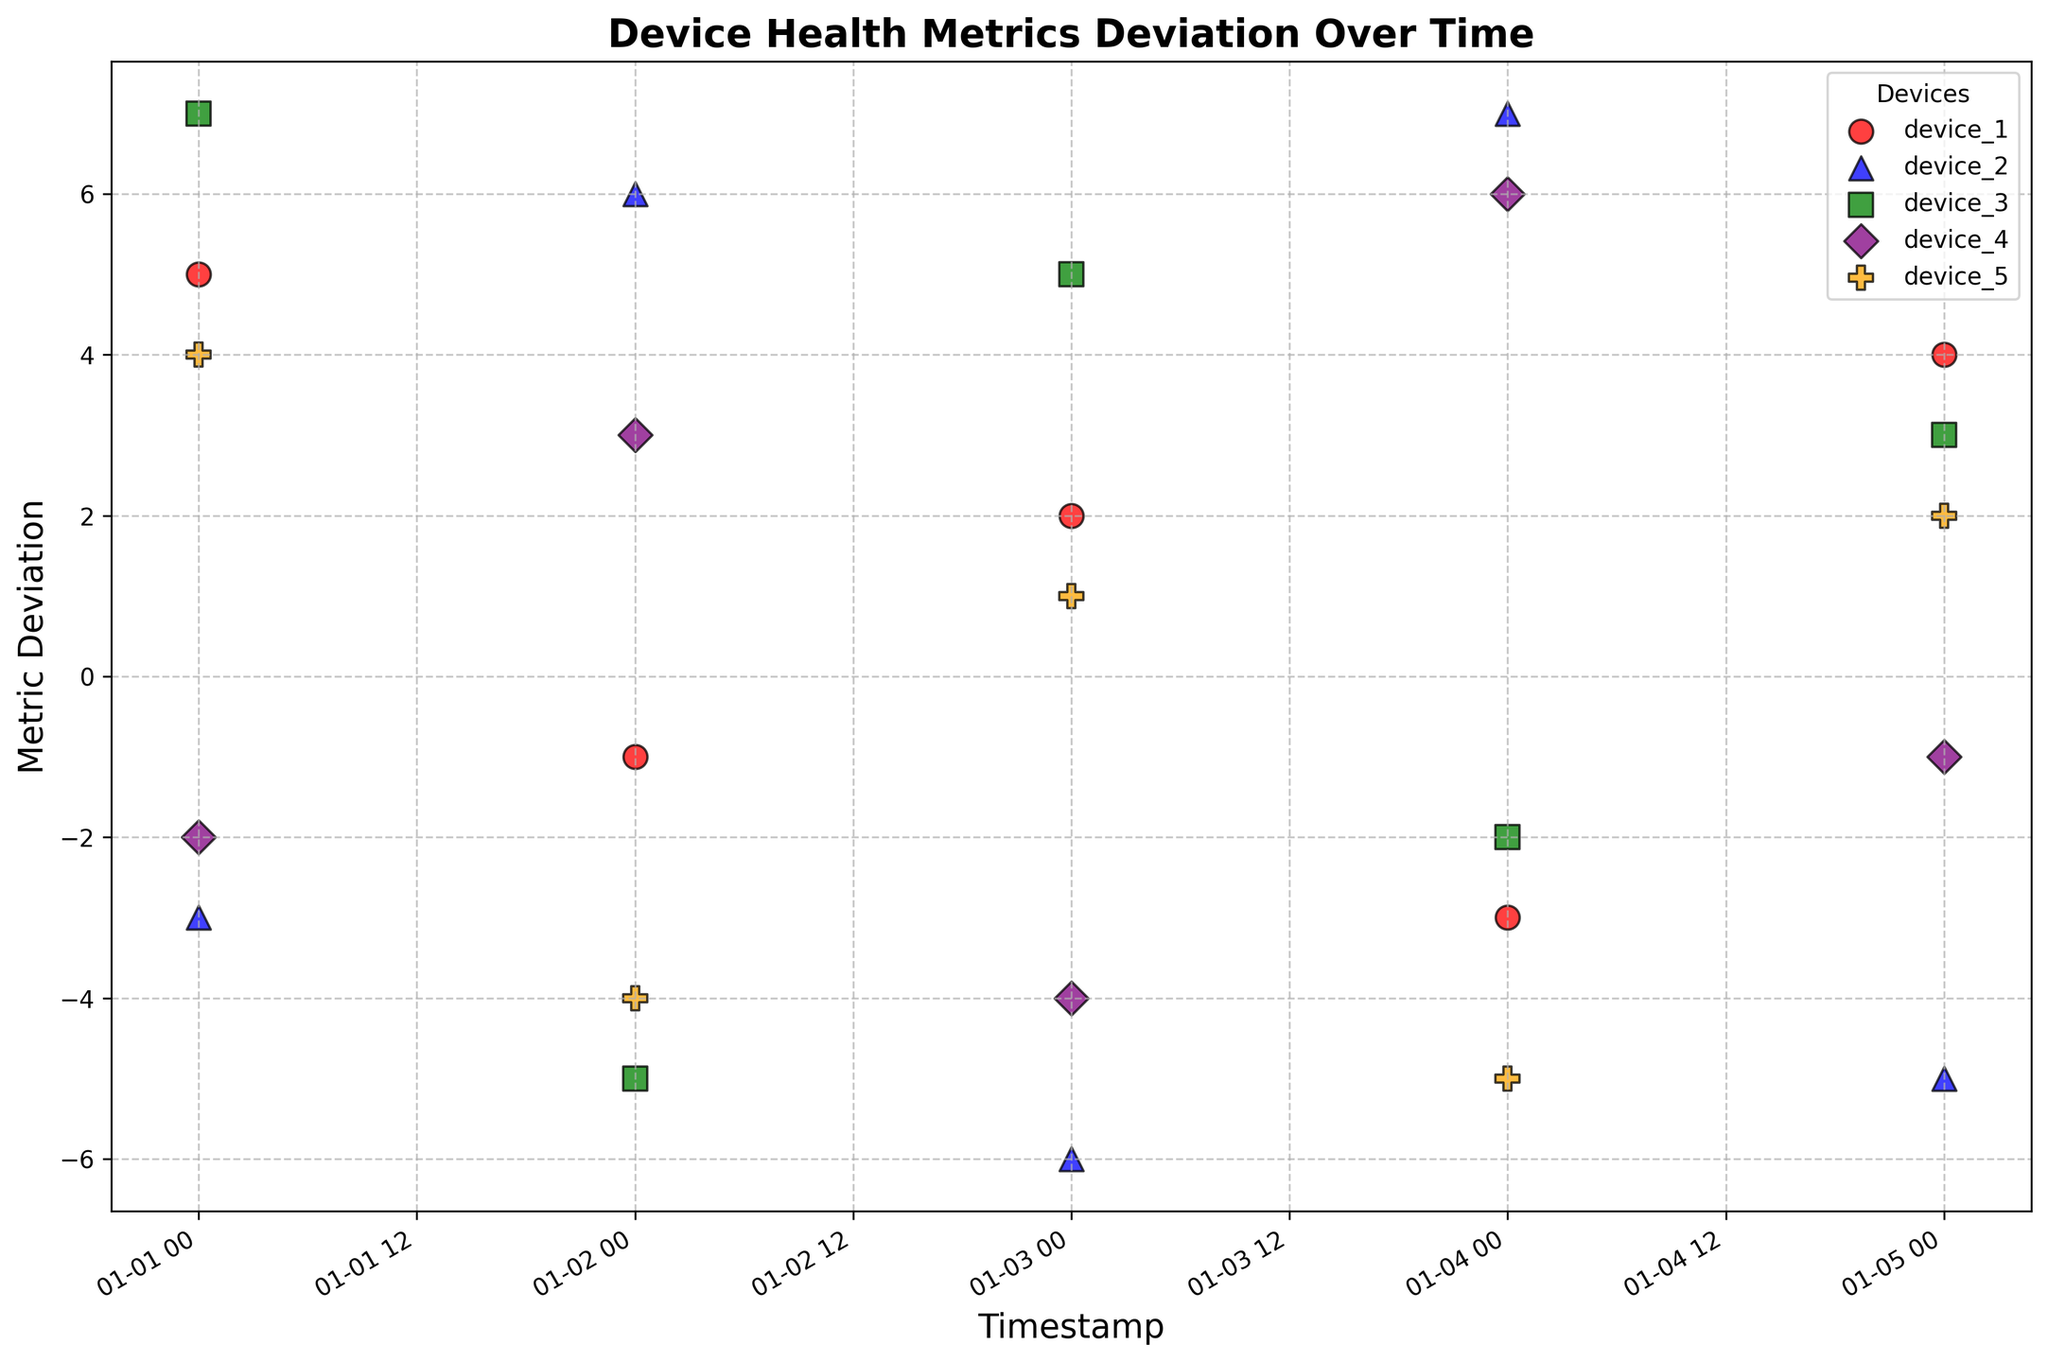What is the trend for device_1's metric deviation over time? By observing the scatter plot, we can follow the trend of the red circles representing device_1's deviations on the y-axis over the dates on the x-axis. The metric values fluctuate with both positive and negative deviations over time, suggesting inconsistency.
Answer: The trend shows inconsistency with both positive and negative deviations Which device experienced the most positive deviation on January 4th, 2023? Look for the points corresponding to January 4th, 2023, and compare their metric deviations. The purple diamond (device_4) has the highest positive value of 6 on that date.
Answer: device_4 On which date did device_3 experience its most negative deviation, and what was the value? Follow the green squares representing device_3's data points and identify the most negative deviation. This is on January 2nd, 2023, with a value of -5.
Answer: January 2nd, 2023, -5 Which device showed the greatest improvement between January 1st and January 2nd, 2023? Compare the metric deviations for each device between these dates. Device_2 improved from -3 to 6, showing the greatest increase of 9 units.
Answer: device_2 What is the average deviation for device_5 over the given dates? Calculate the average of the metric deviations for device_5: (4 - 4 + 1 - 5 + 2)/5 = -0.4.
Answer: -0.4 Compare the number of days where device_2 had positive versus negative deviations. Check the color and marker for device_2 (blue triangles), and count the days with positive and negative values. There are 3 positive days (January 2, 4, 5) and 2 negative days (January 1, 3).
Answer: 3 positive, 2 negative Did any device have consistent positive deviations over time? Verify if any device's data points are all positive. No device has only positive deviations, each has at least one negative deviation.
Answer: No What is the total sum of metric deviations for device_4 over the period? Sum the deviations for device_4: (-2 + 3 - 4 + 6 - 1) = 2.
Answer: 2 